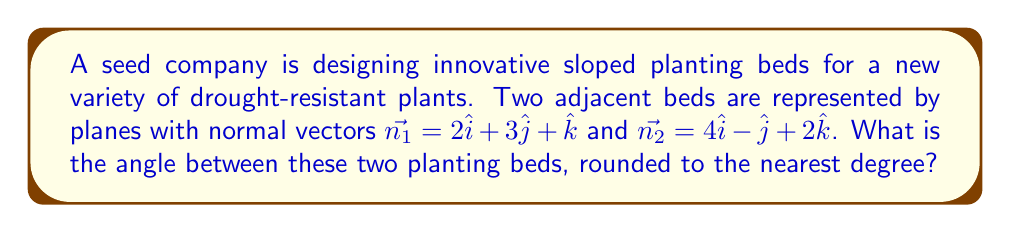Show me your answer to this math problem. To find the angle between two planes, we need to calculate the angle between their normal vectors. We can use the dot product formula:

$$\cos \theta = \frac{\vec{n_1} \cdot \vec{n_2}}{|\vec{n_1}||\vec{n_2}|}$$

Step 1: Calculate the dot product $\vec{n_1} \cdot \vec{n_2}$
$$\vec{n_1} \cdot \vec{n_2} = (2)(4) + (3)(-1) + (1)(2) = 8 - 3 + 2 = 7$$

Step 2: Calculate the magnitudes of the vectors
$$|\vec{n_1}| = \sqrt{2^2 + 3^2 + 1^2} = \sqrt{4 + 9 + 1} = \sqrt{14}$$
$$|\vec{n_2}| = \sqrt{4^2 + (-1)^2 + 2^2} = \sqrt{16 + 1 + 4} = \sqrt{21}$$

Step 3: Substitute into the formula
$$\cos \theta = \frac{7}{\sqrt{14}\sqrt{21}}$$

Step 4: Solve for $\theta$
$$\theta = \arccos\left(\frac{7}{\sqrt{14}\sqrt{21}}\right)$$

Step 5: Calculate and round to the nearest degree
$$\theta \approx 61.02^\circ \approx 61^\circ$$
Answer: The angle between the two planting beds is approximately 61°. 